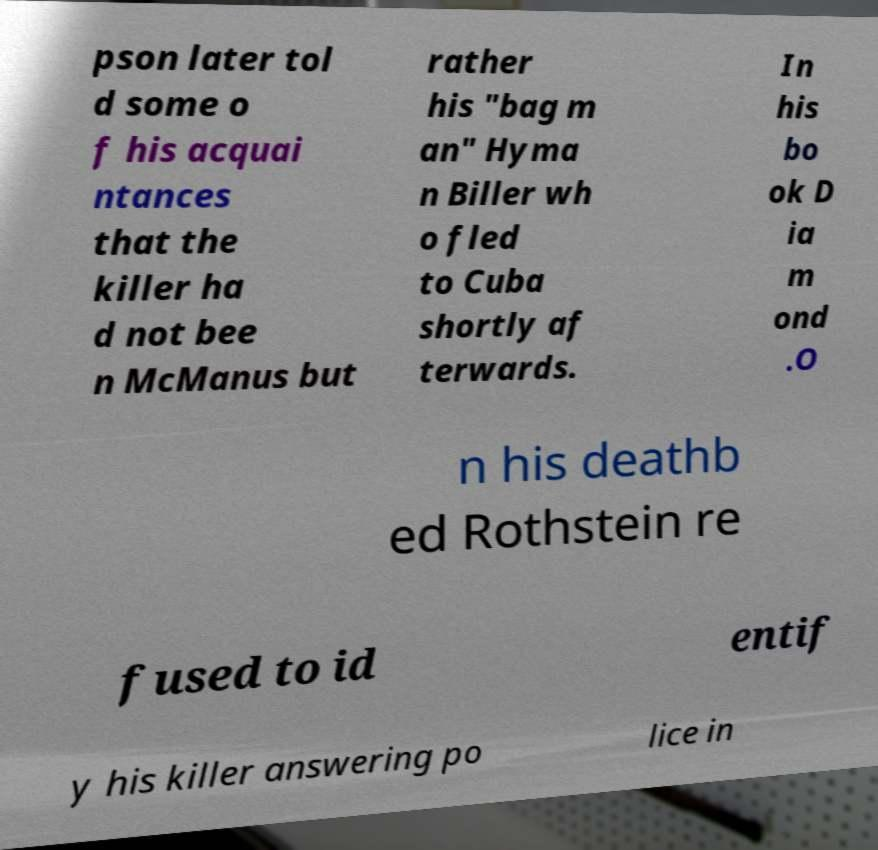Can you accurately transcribe the text from the provided image for me? pson later tol d some o f his acquai ntances that the killer ha d not bee n McManus but rather his "bag m an" Hyma n Biller wh o fled to Cuba shortly af terwards. In his bo ok D ia m ond .O n his deathb ed Rothstein re fused to id entif y his killer answering po lice in 